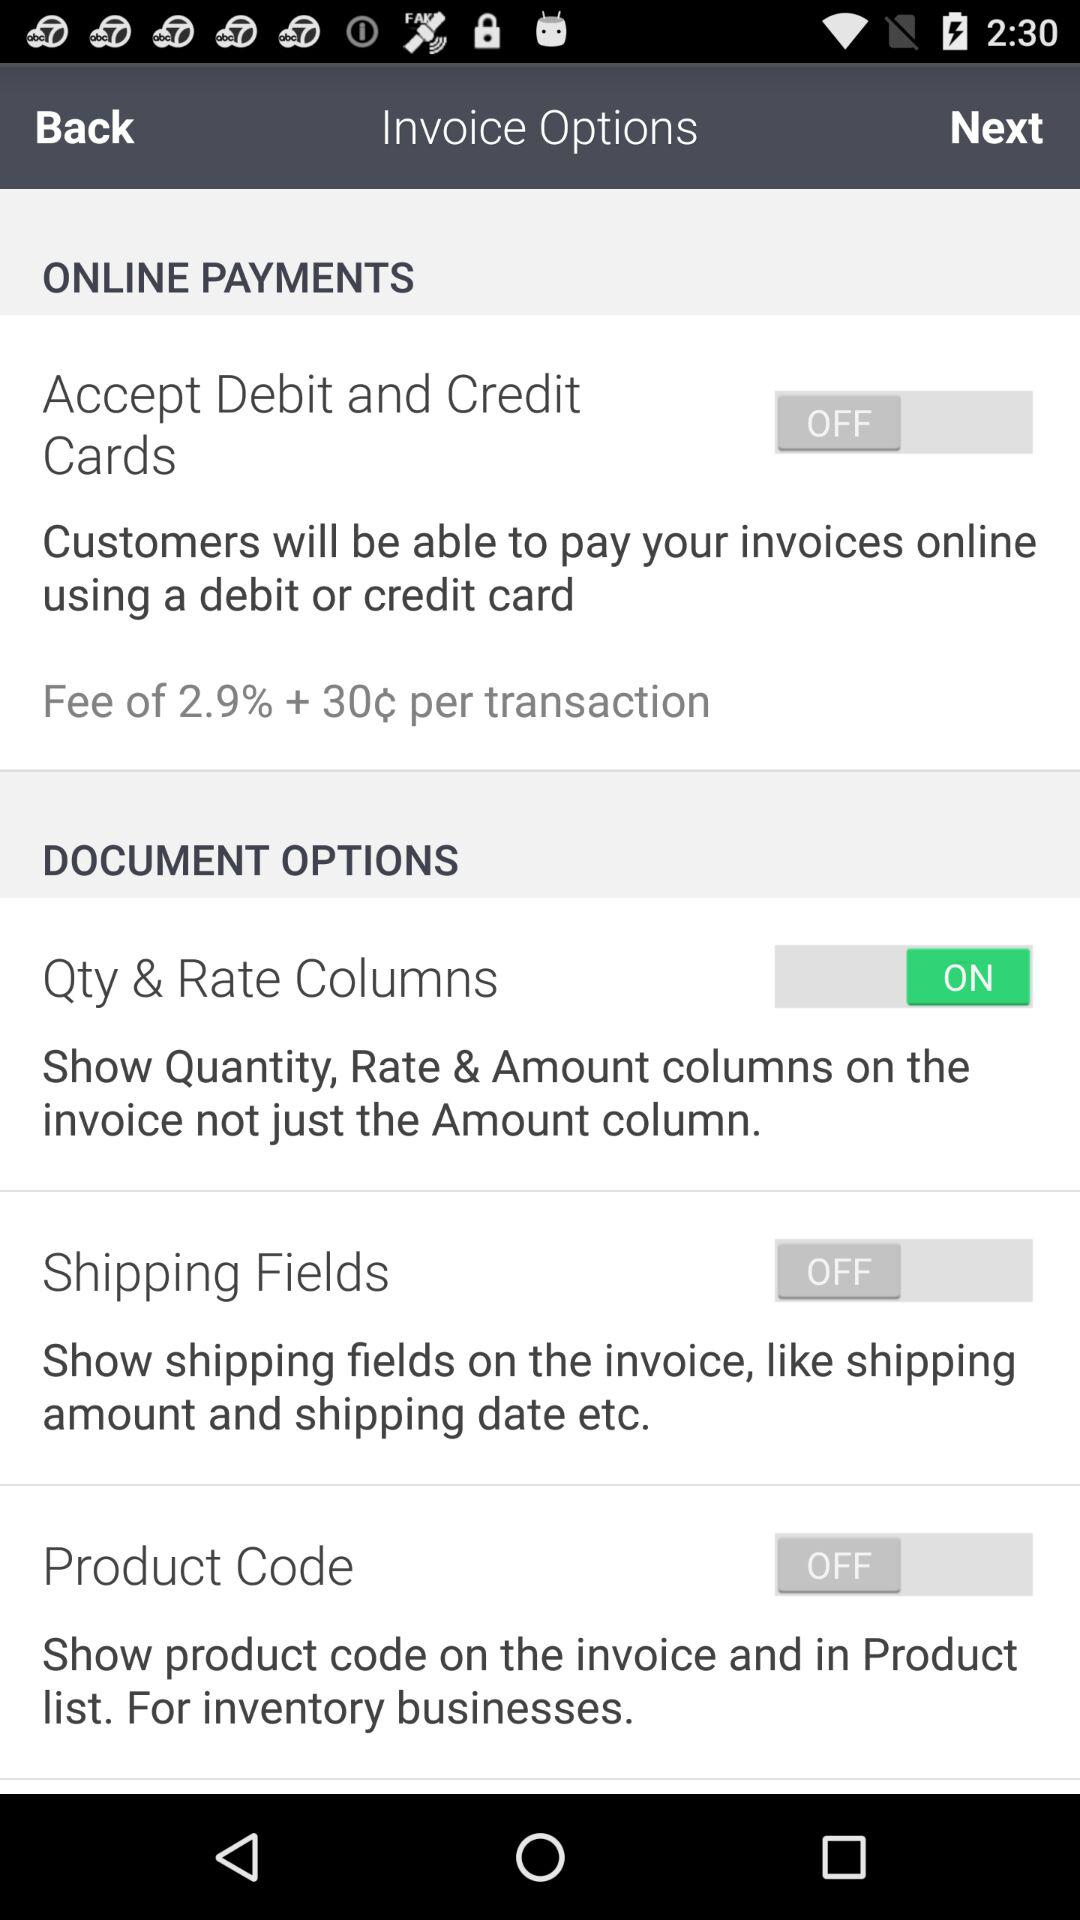What is the fee and transaction charges for a debit and credit card? The fee and transaction charges for debit and credit card is "Fee of 2.9% + 30c per transaction". 